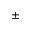<formula> <loc_0><loc_0><loc_500><loc_500>\pm</formula> 